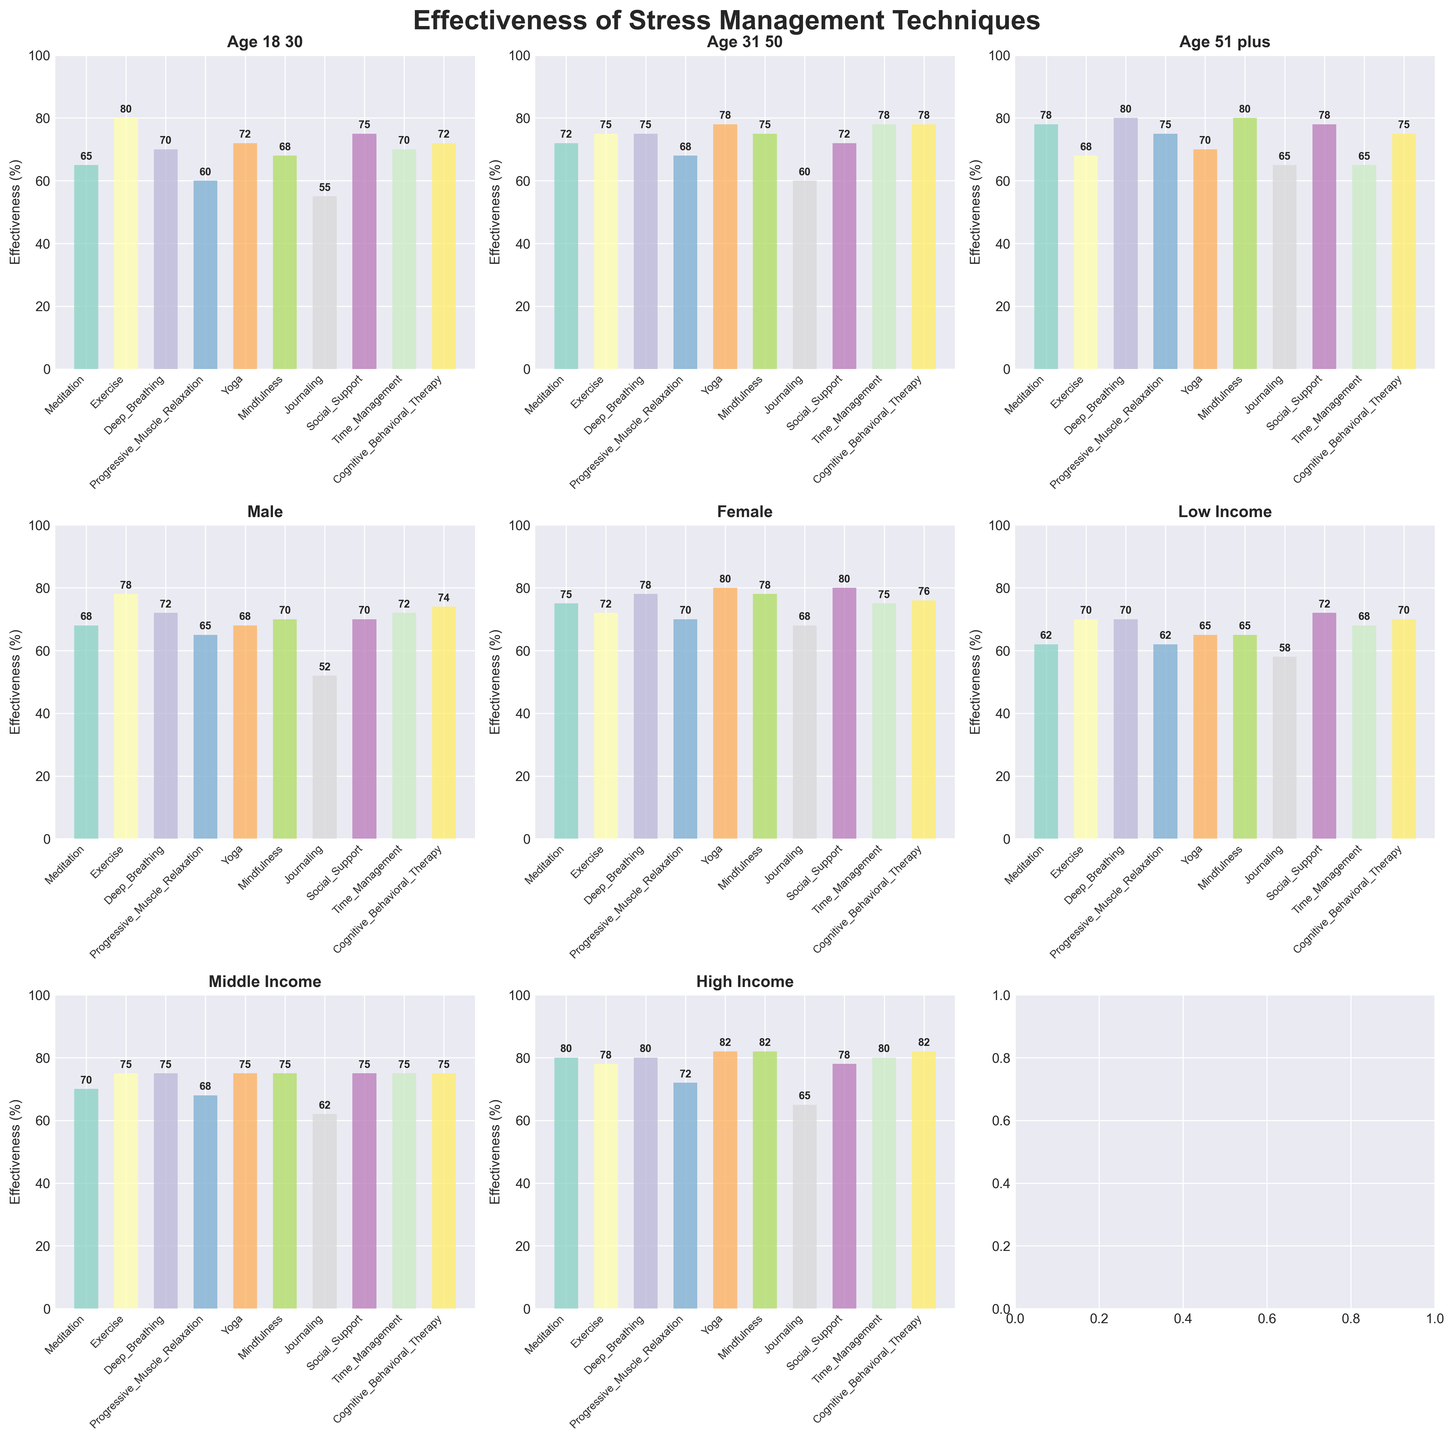What's the title of the figure? The title is usually displayed at the top of the figure.
Answer: Effectiveness of Stress Management Techniques Which technique is most effective for people aged 31-50? Look at the subplot titled "Age 31 50" and find the highest bar.
Answer: Time Management Which technique shows the least effectiveness for low-income groups? Observe the subplot titled "Low Income" and identify the shortest bar.
Answer: Journaling Is Progressive Muscle Relaxation more effective for males or females? Compare the heights of the bars for Progressive Muscle Relaxation in both the "Male" and "Female" subplots.
Answer: Females How does effectiveness of Yoga differ among age groups? Observe the bars for Yoga in the subplots "Age 18 30", "Age 31 50", and "Age 51 plus" and compare the values.
Answer: 72 (Age 18-30), 78 (Age 31-50), 70 (Age 51+) What's the average effectiveness of Cognitive Behavioral Therapy across different income groups? Sum the effectiveness values of Cognitive Behavioral Therapy in "Low Income", "Middle Income", and "High Income" subplots and divide by 3.
Answer: (70 + 75 + 82) / 3 = 75.67 Which technique has the highest average effectiveness across all demographic groups displayed? Calculate the average effectiveness for each technique across all subplots and identify the highest one.
Answer: Mindfulness and Yoga Between Meditation and Deep Breathing, which is more effective for people aged 51 and above? Compare their effectiveness values in the "Age 51 plus" subplot.
Answer: Deep Breathing By how much does the effectiveness of Social Support differ between males and females? Subtract the effectiveness value for Social Support in the "Male" subplot from that in the "Female" subplot.
Answer: 80 - 70 = 10 Which technique is more effective for high income groups compared to low income groups? Compare the bars for each technique in the "High Income" and "Low Income" subplots and find the one with the biggest positive difference.
Answer: Yoga and Mindfulness 